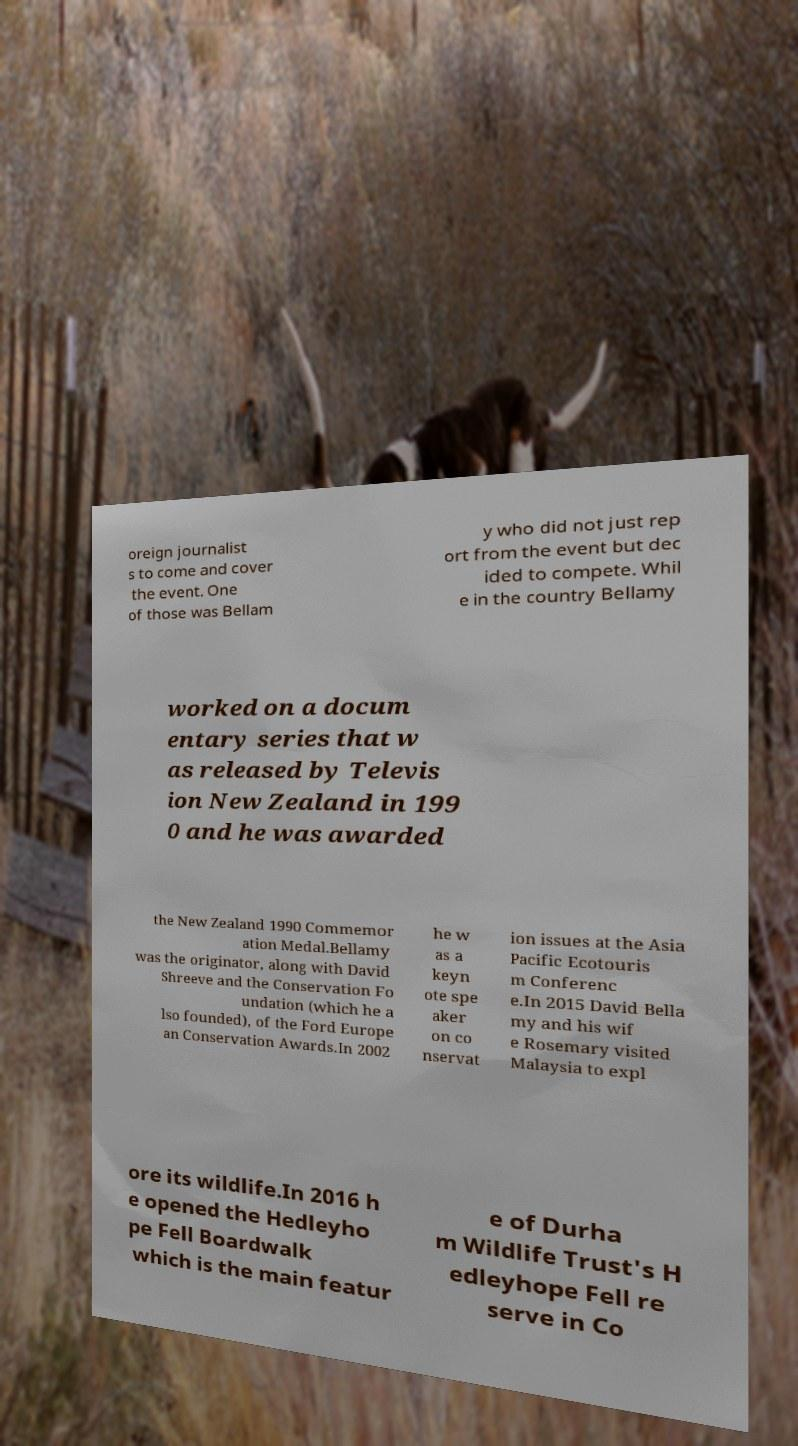For documentation purposes, I need the text within this image transcribed. Could you provide that? oreign journalist s to come and cover the event. One of those was Bellam y who did not just rep ort from the event but dec ided to compete. Whil e in the country Bellamy worked on a docum entary series that w as released by Televis ion New Zealand in 199 0 and he was awarded the New Zealand 1990 Commemor ation Medal.Bellamy was the originator, along with David Shreeve and the Conservation Fo undation (which he a lso founded), of the Ford Europe an Conservation Awards.In 2002 he w as a keyn ote spe aker on co nservat ion issues at the Asia Pacific Ecotouris m Conferenc e.In 2015 David Bella my and his wif e Rosemary visited Malaysia to expl ore its wildlife.In 2016 h e opened the Hedleyho pe Fell Boardwalk which is the main featur e of Durha m Wildlife Trust's H edleyhope Fell re serve in Co 